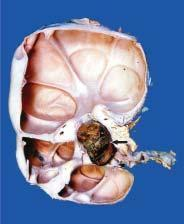s the cystic change seen to extend into renal p arenchyma, compressing the cortex as a thin rim at the periphery?
Answer the question using a single word or phrase. Yes 